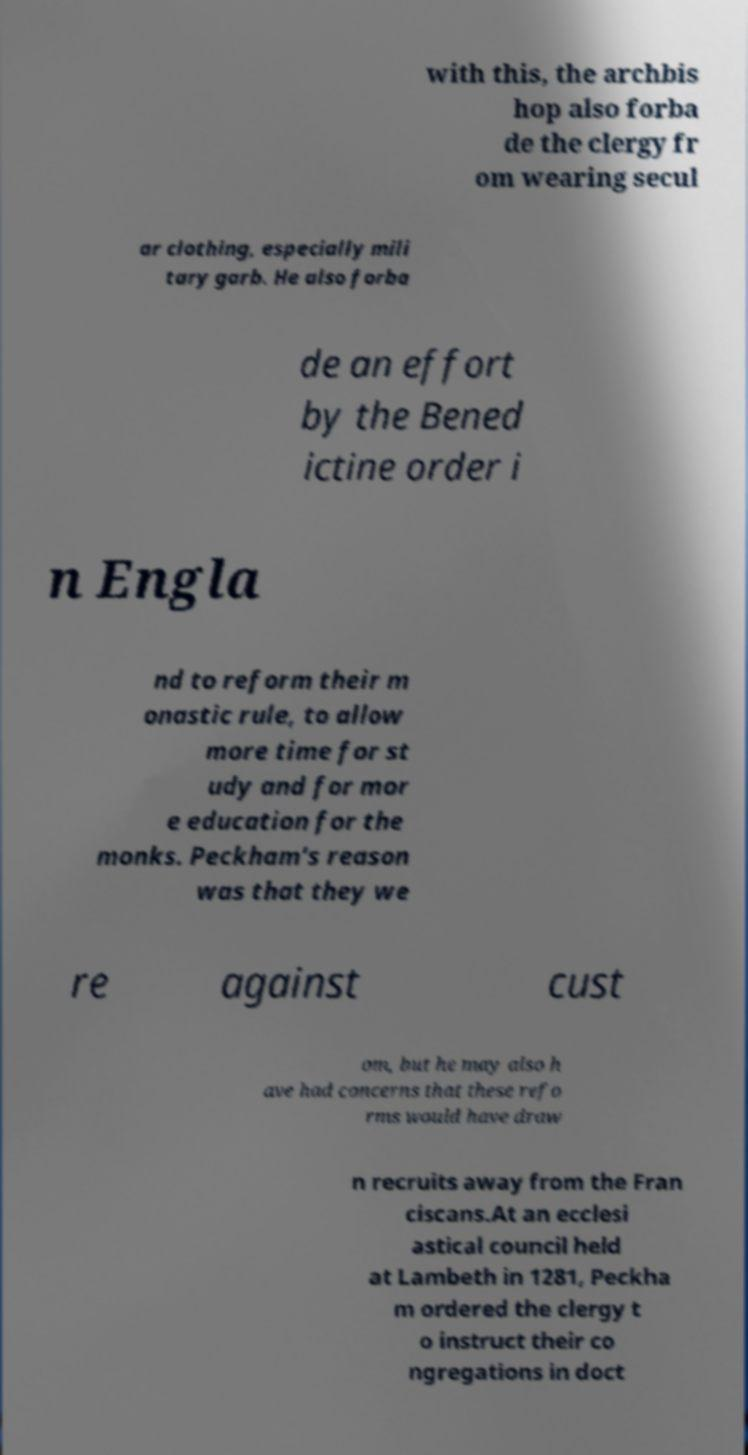What messages or text are displayed in this image? I need them in a readable, typed format. with this, the archbis hop also forba de the clergy fr om wearing secul ar clothing, especially mili tary garb. He also forba de an effort by the Bened ictine order i n Engla nd to reform their m onastic rule, to allow more time for st udy and for mor e education for the monks. Peckham's reason was that they we re against cust om, but he may also h ave had concerns that these refo rms would have draw n recruits away from the Fran ciscans.At an ecclesi astical council held at Lambeth in 1281, Peckha m ordered the clergy t o instruct their co ngregations in doct 